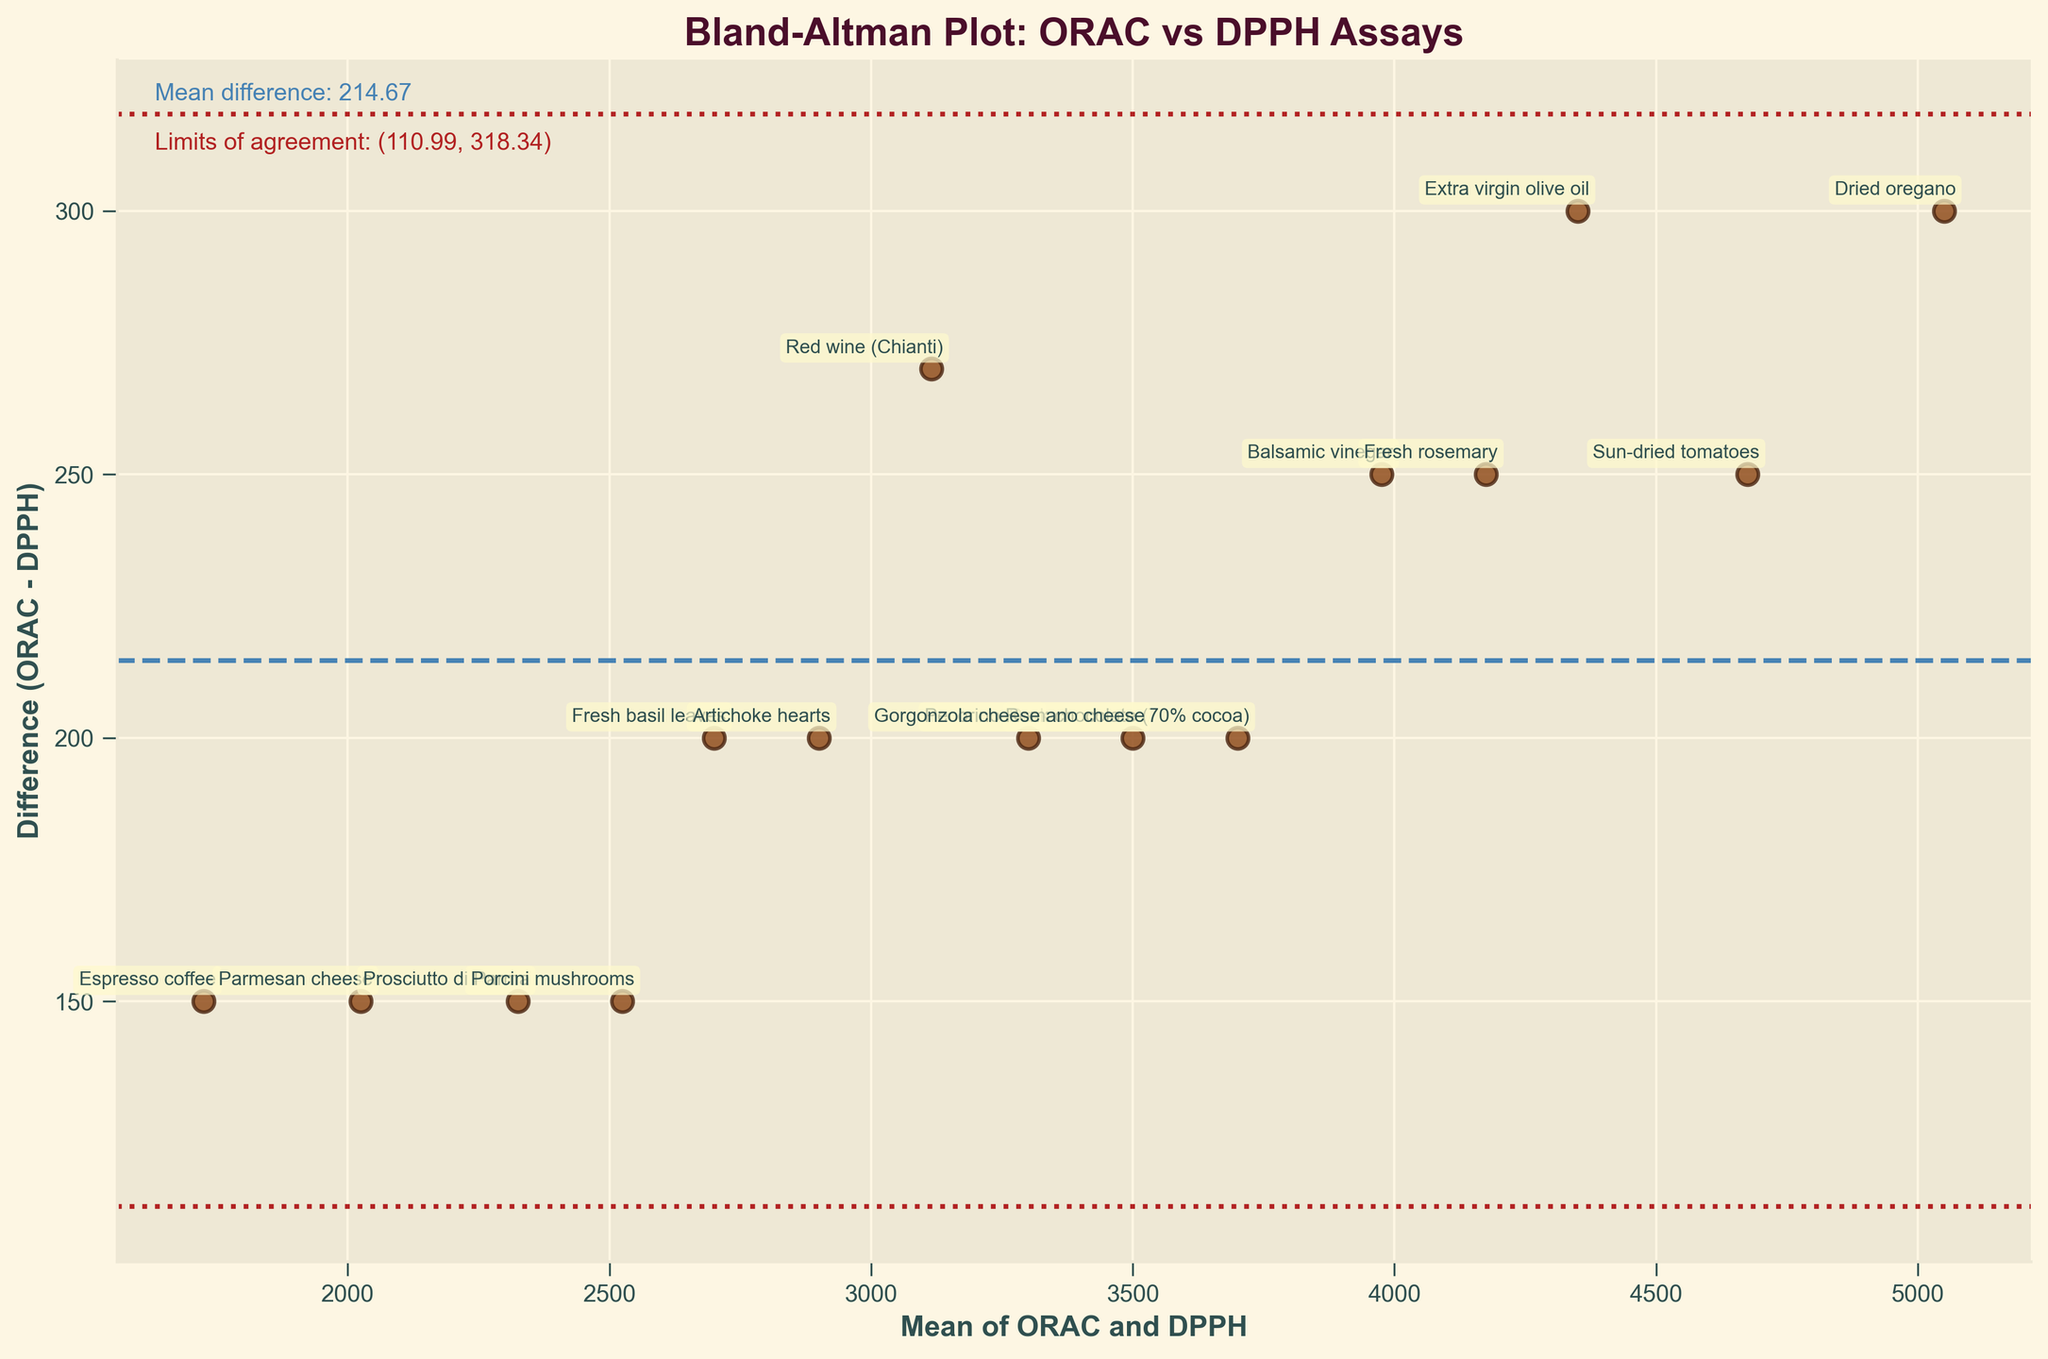What is the title of the plot? The title is displayed at the top of the plot, typically in bold and larger font size. Here, the title "Bland-Altman Plot: ORAC vs DPPH Assays" is visible.
Answer: Bland-Altman Plot: ORAC vs DPPH Assays How many data points are plotted in the figure? The number of data points can be counted by looking at the number of scatter points on the plot. Each point has been labeled with a sample name.
Answer: 15 Which sample has the largest positive difference between ORAC and DPPH? The largest positive difference can be determined by looking at the point that is furthest above the mean difference line and annotating the corresponding sample.
Answer: Dried oregano What are the limits of agreement? The limits of agreement are shown as horizontal dashed lines and are labeled with their values. From the plot, these limits are the extreme dashed lines in red.
Answer: (-120.44, 584.11) What is the mean difference between ORAC and DPPH? The mean difference is indicated by a dashed horizontal line in the plot, and there is a labeled value near the top of the figure stating "Mean difference: 231.83".
Answer: 231.83 How many samples show a negative difference between ORAC and DPPH? The negative difference points fall below the horizontal mean difference line. By counting these points, we can find the number of samples.
Answer: 0 Which sample is closest to the mean difference line? The closest sample to the mean difference line is the one whose difference is nearest to the mean value of 231.83, determined visually or by annotation proximity.
Answer: Fresh rosemary Identify a sample that lies outside the limits of agreement. A sample outside the limits of agreement will be located beyond the outer dashed red lines. All points lying beyond these lines in vertical positions meet this criterion.
Answer: There are no samples outside the limits of agreement Which sample has the smallest mean of ORAC and DPPH? The smallest mean is found by identifying the leftmost point on the x-axis, which represents the mean of ORAC and DPPH values.
Answer: Espresso coffee What color and shape are used to plot the scatter points? The scatter points' color and shape are determined by the plot's appearance. These appear circular in shape and are brownish in color.
Answer: Brown circular points 